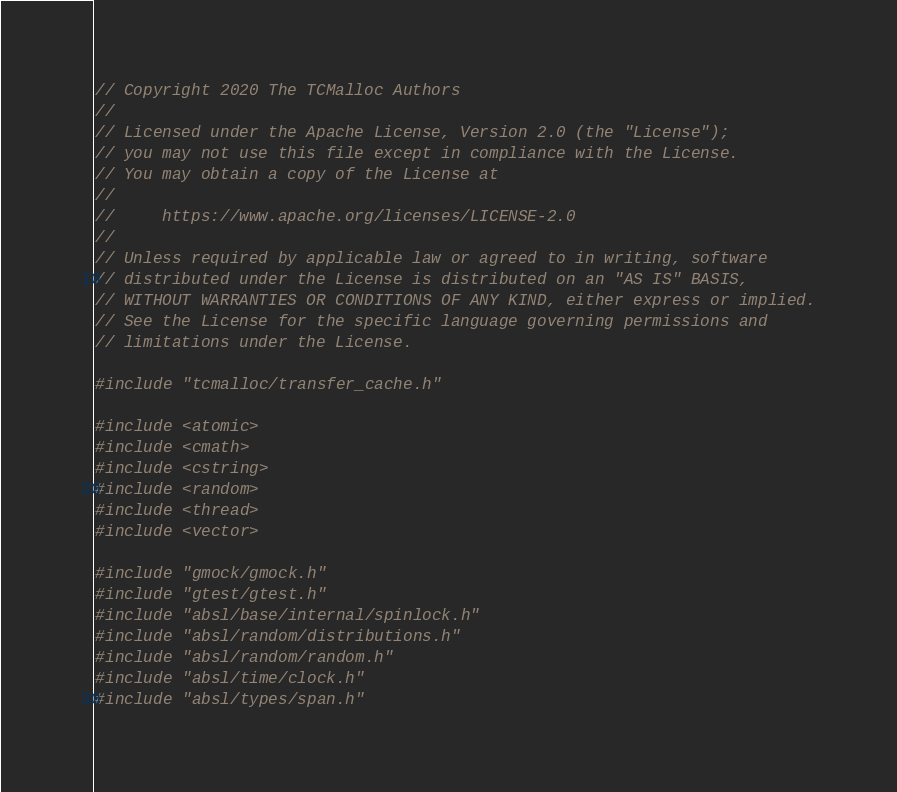<code> <loc_0><loc_0><loc_500><loc_500><_C++_>// Copyright 2020 The TCMalloc Authors
//
// Licensed under the Apache License, Version 2.0 (the "License");
// you may not use this file except in compliance with the License.
// You may obtain a copy of the License at
//
//     https://www.apache.org/licenses/LICENSE-2.0
//
// Unless required by applicable law or agreed to in writing, software
// distributed under the License is distributed on an "AS IS" BASIS,
// WITHOUT WARRANTIES OR CONDITIONS OF ANY KIND, either express or implied.
// See the License for the specific language governing permissions and
// limitations under the License.

#include "tcmalloc/transfer_cache.h"

#include <atomic>
#include <cmath>
#include <cstring>
#include <random>
#include <thread>
#include <vector>

#include "gmock/gmock.h"
#include "gtest/gtest.h"
#include "absl/base/internal/spinlock.h"
#include "absl/random/distributions.h"
#include "absl/random/random.h"
#include "absl/time/clock.h"
#include "absl/types/span.h"</code> 